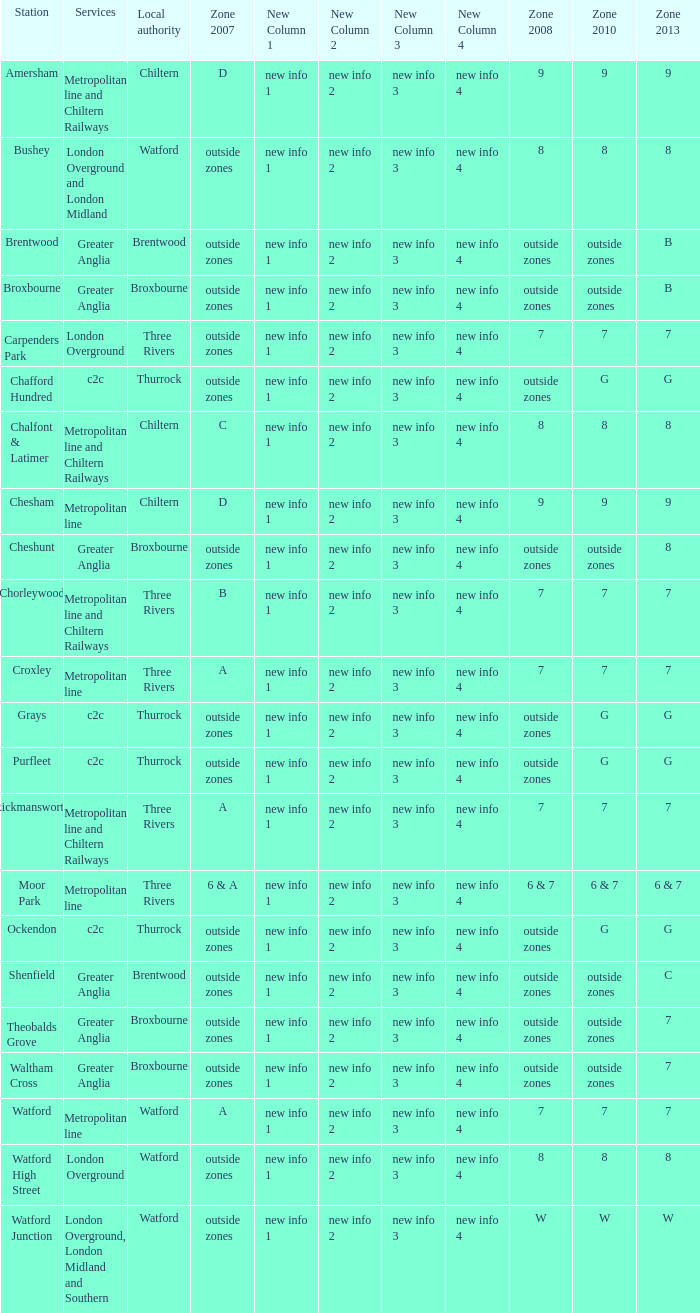Could you parse the entire table? {'header': ['Station', 'Services', 'Local authority', 'Zone 2007', 'New Column 1', 'New Column 2', 'New Column 3', 'New Column 4', 'Zone 2008', 'Zone 2010', 'Zone 2013'], 'rows': [['Amersham', 'Metropolitan line and Chiltern Railways', 'Chiltern', 'D', 'new info 1', 'new info 2', 'new info 3', 'new info 4', '9', '9', '9'], ['Bushey', 'London Overground and London Midland', 'Watford', 'outside zones', 'new info 1', 'new info 2', 'new info 3', 'new info 4', '8', '8', '8'], ['Brentwood', 'Greater Anglia', 'Brentwood', 'outside zones', 'new info 1', 'new info 2', 'new info 3', 'new info 4', 'outside zones', 'outside zones', 'B'], ['Broxbourne', 'Greater Anglia', 'Broxbourne', 'outside zones', 'new info 1', 'new info 2', 'new info 3', 'new info 4', 'outside zones', 'outside zones', 'B'], ['Carpenders Park', 'London Overground', 'Three Rivers', 'outside zones', 'new info 1', 'new info 2', 'new info 3', 'new info 4', '7', '7', '7'], ['Chafford Hundred', 'c2c', 'Thurrock', 'outside zones', 'new info 1', 'new info 2', 'new info 3', 'new info 4', 'outside zones', 'G', 'G'], ['Chalfont & Latimer', 'Metropolitan line and Chiltern Railways', 'Chiltern', 'C', 'new info 1', 'new info 2', 'new info 3', 'new info 4', '8', '8', '8'], ['Chesham', 'Metropolitan line', 'Chiltern', 'D', 'new info 1', 'new info 2', 'new info 3', 'new info 4', '9', '9', '9'], ['Cheshunt', 'Greater Anglia', 'Broxbourne', 'outside zones', 'new info 1', 'new info 2', 'new info 3', 'new info 4', 'outside zones', 'outside zones', '8'], ['Chorleywood', 'Metropolitan line and Chiltern Railways', 'Three Rivers', 'B', 'new info 1', 'new info 2', 'new info 3', 'new info 4', '7', '7', '7'], ['Croxley', 'Metropolitan line', 'Three Rivers', 'A', 'new info 1', 'new info 2', 'new info 3', 'new info 4', '7', '7', '7'], ['Grays', 'c2c', 'Thurrock', 'outside zones', 'new info 1', 'new info 2', 'new info 3', 'new info 4', 'outside zones', 'G', 'G'], ['Purfleet', 'c2c', 'Thurrock', 'outside zones', 'new info 1', 'new info 2', 'new info 3', 'new info 4', 'outside zones', 'G', 'G'], ['Rickmansworth', 'Metropolitan line and Chiltern Railways', 'Three Rivers', 'A', 'new info 1', 'new info 2', 'new info 3', 'new info 4', '7', '7', '7'], ['Moor Park', 'Metropolitan line', 'Three Rivers', '6 & A', 'new info 1', 'new info 2', 'new info 3', 'new info 4', '6 & 7', '6 & 7', '6 & 7'], ['Ockendon', 'c2c', 'Thurrock', 'outside zones', 'new info 1', 'new info 2', 'new info 3', 'new info 4', 'outside zones', 'G', 'G'], ['Shenfield', 'Greater Anglia', 'Brentwood', 'outside zones', 'new info 1', 'new info 2', 'new info 3', 'new info 4', 'outside zones', 'outside zones', 'C'], ['Theobalds Grove', 'Greater Anglia', 'Broxbourne', 'outside zones', 'new info 1', 'new info 2', 'new info 3', 'new info 4', 'outside zones', 'outside zones', '7'], ['Waltham Cross', 'Greater Anglia', 'Broxbourne', 'outside zones', 'new info 1', 'new info 2', 'new info 3', 'new info 4', 'outside zones', 'outside zones', '7'], ['Watford', 'Metropolitan line', 'Watford', 'A', 'new info 1', 'new info 2', 'new info 3', 'new info 4', '7', '7', '7'], ['Watford High Street', 'London Overground', 'Watford', 'outside zones', 'new info 1', 'new info 2', 'new info 3', 'new info 4', '8', '8', '8'], ['Watford Junction', 'London Overground, London Midland and Southern', 'Watford', 'outside zones', 'new info 1', 'new info 2', 'new info 3', 'new info 4', 'W', 'W', 'W']]} Which Services have a Local authority of chiltern, and a Zone 2010 of 9? Metropolitan line and Chiltern Railways, Metropolitan line. 